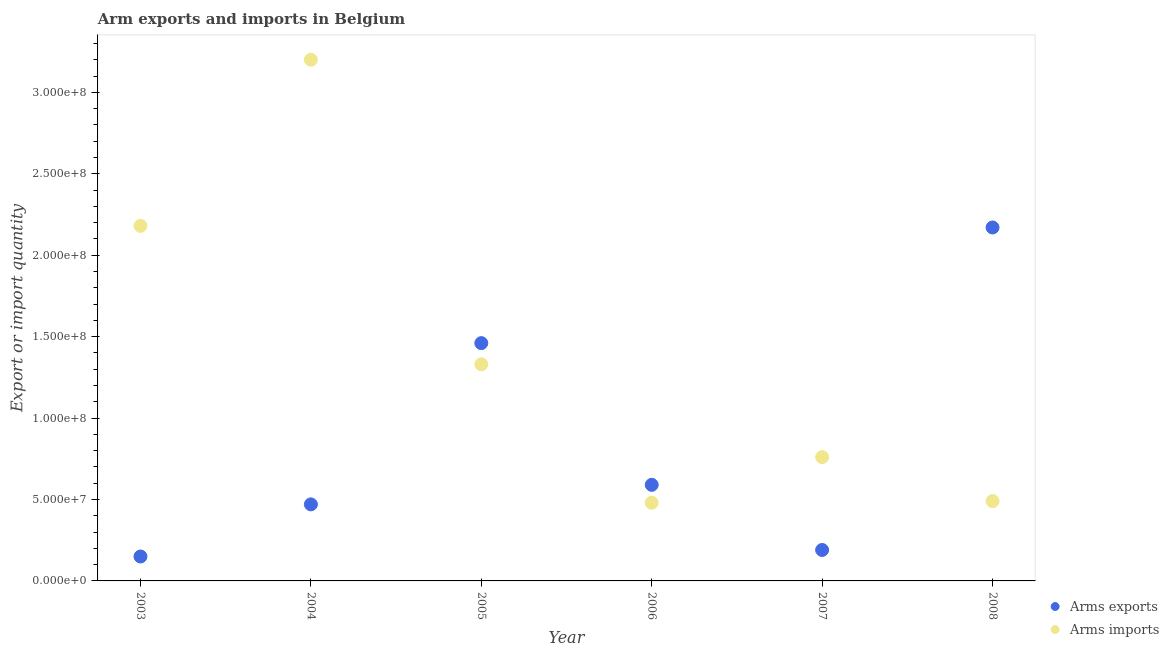How many different coloured dotlines are there?
Your answer should be compact. 2. Is the number of dotlines equal to the number of legend labels?
Keep it short and to the point. Yes. What is the arms imports in 2008?
Provide a short and direct response. 4.90e+07. Across all years, what is the maximum arms imports?
Keep it short and to the point. 3.20e+08. Across all years, what is the minimum arms imports?
Give a very brief answer. 4.80e+07. In which year was the arms exports maximum?
Offer a terse response. 2008. What is the total arms imports in the graph?
Your answer should be very brief. 8.44e+08. What is the difference between the arms imports in 2003 and that in 2006?
Give a very brief answer. 1.70e+08. What is the difference between the arms exports in 2008 and the arms imports in 2005?
Give a very brief answer. 8.40e+07. What is the average arms imports per year?
Your answer should be compact. 1.41e+08. In the year 2007, what is the difference between the arms imports and arms exports?
Make the answer very short. 5.70e+07. In how many years, is the arms exports greater than 220000000?
Give a very brief answer. 0. What is the ratio of the arms imports in 2003 to that in 2004?
Your answer should be compact. 0.68. Is the arms exports in 2004 less than that in 2008?
Offer a very short reply. Yes. What is the difference between the highest and the second highest arms exports?
Your answer should be compact. 7.10e+07. What is the difference between the highest and the lowest arms imports?
Provide a short and direct response. 2.72e+08. In how many years, is the arms imports greater than the average arms imports taken over all years?
Offer a terse response. 2. Does the arms exports monotonically increase over the years?
Offer a terse response. No. Is the arms imports strictly greater than the arms exports over the years?
Offer a very short reply. No. How many years are there in the graph?
Your answer should be very brief. 6. Are the values on the major ticks of Y-axis written in scientific E-notation?
Offer a very short reply. Yes. How many legend labels are there?
Your response must be concise. 2. What is the title of the graph?
Ensure brevity in your answer.  Arm exports and imports in Belgium. What is the label or title of the X-axis?
Offer a terse response. Year. What is the label or title of the Y-axis?
Make the answer very short. Export or import quantity. What is the Export or import quantity of Arms exports in 2003?
Offer a terse response. 1.50e+07. What is the Export or import quantity of Arms imports in 2003?
Give a very brief answer. 2.18e+08. What is the Export or import quantity in Arms exports in 2004?
Your answer should be compact. 4.70e+07. What is the Export or import quantity of Arms imports in 2004?
Offer a terse response. 3.20e+08. What is the Export or import quantity in Arms exports in 2005?
Offer a terse response. 1.46e+08. What is the Export or import quantity of Arms imports in 2005?
Your answer should be very brief. 1.33e+08. What is the Export or import quantity of Arms exports in 2006?
Provide a short and direct response. 5.90e+07. What is the Export or import quantity in Arms imports in 2006?
Offer a very short reply. 4.80e+07. What is the Export or import quantity in Arms exports in 2007?
Your answer should be compact. 1.90e+07. What is the Export or import quantity in Arms imports in 2007?
Offer a terse response. 7.60e+07. What is the Export or import quantity in Arms exports in 2008?
Provide a succinct answer. 2.17e+08. What is the Export or import quantity of Arms imports in 2008?
Your answer should be very brief. 4.90e+07. Across all years, what is the maximum Export or import quantity in Arms exports?
Offer a very short reply. 2.17e+08. Across all years, what is the maximum Export or import quantity of Arms imports?
Your answer should be compact. 3.20e+08. Across all years, what is the minimum Export or import quantity in Arms exports?
Provide a succinct answer. 1.50e+07. Across all years, what is the minimum Export or import quantity of Arms imports?
Your answer should be compact. 4.80e+07. What is the total Export or import quantity of Arms exports in the graph?
Provide a succinct answer. 5.03e+08. What is the total Export or import quantity of Arms imports in the graph?
Give a very brief answer. 8.44e+08. What is the difference between the Export or import quantity in Arms exports in 2003 and that in 2004?
Give a very brief answer. -3.20e+07. What is the difference between the Export or import quantity of Arms imports in 2003 and that in 2004?
Make the answer very short. -1.02e+08. What is the difference between the Export or import quantity in Arms exports in 2003 and that in 2005?
Provide a short and direct response. -1.31e+08. What is the difference between the Export or import quantity in Arms imports in 2003 and that in 2005?
Give a very brief answer. 8.50e+07. What is the difference between the Export or import quantity in Arms exports in 2003 and that in 2006?
Make the answer very short. -4.40e+07. What is the difference between the Export or import quantity of Arms imports in 2003 and that in 2006?
Provide a succinct answer. 1.70e+08. What is the difference between the Export or import quantity in Arms imports in 2003 and that in 2007?
Your response must be concise. 1.42e+08. What is the difference between the Export or import quantity of Arms exports in 2003 and that in 2008?
Provide a short and direct response. -2.02e+08. What is the difference between the Export or import quantity of Arms imports in 2003 and that in 2008?
Ensure brevity in your answer.  1.69e+08. What is the difference between the Export or import quantity of Arms exports in 2004 and that in 2005?
Ensure brevity in your answer.  -9.90e+07. What is the difference between the Export or import quantity of Arms imports in 2004 and that in 2005?
Give a very brief answer. 1.87e+08. What is the difference between the Export or import quantity of Arms exports in 2004 and that in 2006?
Your answer should be compact. -1.20e+07. What is the difference between the Export or import quantity in Arms imports in 2004 and that in 2006?
Your answer should be compact. 2.72e+08. What is the difference between the Export or import quantity of Arms exports in 2004 and that in 2007?
Offer a very short reply. 2.80e+07. What is the difference between the Export or import quantity of Arms imports in 2004 and that in 2007?
Offer a very short reply. 2.44e+08. What is the difference between the Export or import quantity in Arms exports in 2004 and that in 2008?
Your answer should be very brief. -1.70e+08. What is the difference between the Export or import quantity of Arms imports in 2004 and that in 2008?
Offer a terse response. 2.71e+08. What is the difference between the Export or import quantity in Arms exports in 2005 and that in 2006?
Your response must be concise. 8.70e+07. What is the difference between the Export or import quantity of Arms imports in 2005 and that in 2006?
Keep it short and to the point. 8.50e+07. What is the difference between the Export or import quantity in Arms exports in 2005 and that in 2007?
Offer a terse response. 1.27e+08. What is the difference between the Export or import quantity of Arms imports in 2005 and that in 2007?
Your answer should be very brief. 5.70e+07. What is the difference between the Export or import quantity in Arms exports in 2005 and that in 2008?
Make the answer very short. -7.10e+07. What is the difference between the Export or import quantity of Arms imports in 2005 and that in 2008?
Provide a short and direct response. 8.40e+07. What is the difference between the Export or import quantity of Arms exports in 2006 and that in 2007?
Keep it short and to the point. 4.00e+07. What is the difference between the Export or import quantity of Arms imports in 2006 and that in 2007?
Offer a very short reply. -2.80e+07. What is the difference between the Export or import quantity of Arms exports in 2006 and that in 2008?
Your answer should be compact. -1.58e+08. What is the difference between the Export or import quantity of Arms exports in 2007 and that in 2008?
Your answer should be compact. -1.98e+08. What is the difference between the Export or import quantity of Arms imports in 2007 and that in 2008?
Ensure brevity in your answer.  2.70e+07. What is the difference between the Export or import quantity in Arms exports in 2003 and the Export or import quantity in Arms imports in 2004?
Give a very brief answer. -3.05e+08. What is the difference between the Export or import quantity in Arms exports in 2003 and the Export or import quantity in Arms imports in 2005?
Your answer should be very brief. -1.18e+08. What is the difference between the Export or import quantity in Arms exports in 2003 and the Export or import quantity in Arms imports in 2006?
Your response must be concise. -3.30e+07. What is the difference between the Export or import quantity in Arms exports in 2003 and the Export or import quantity in Arms imports in 2007?
Give a very brief answer. -6.10e+07. What is the difference between the Export or import quantity in Arms exports in 2003 and the Export or import quantity in Arms imports in 2008?
Your answer should be compact. -3.40e+07. What is the difference between the Export or import quantity in Arms exports in 2004 and the Export or import quantity in Arms imports in 2005?
Your answer should be very brief. -8.60e+07. What is the difference between the Export or import quantity in Arms exports in 2004 and the Export or import quantity in Arms imports in 2006?
Make the answer very short. -1.00e+06. What is the difference between the Export or import quantity of Arms exports in 2004 and the Export or import quantity of Arms imports in 2007?
Ensure brevity in your answer.  -2.90e+07. What is the difference between the Export or import quantity of Arms exports in 2005 and the Export or import quantity of Arms imports in 2006?
Give a very brief answer. 9.80e+07. What is the difference between the Export or import quantity in Arms exports in 2005 and the Export or import quantity in Arms imports in 2007?
Your answer should be compact. 7.00e+07. What is the difference between the Export or import quantity in Arms exports in 2005 and the Export or import quantity in Arms imports in 2008?
Your response must be concise. 9.70e+07. What is the difference between the Export or import quantity of Arms exports in 2006 and the Export or import quantity of Arms imports in 2007?
Offer a very short reply. -1.70e+07. What is the difference between the Export or import quantity of Arms exports in 2006 and the Export or import quantity of Arms imports in 2008?
Your response must be concise. 1.00e+07. What is the difference between the Export or import quantity of Arms exports in 2007 and the Export or import quantity of Arms imports in 2008?
Provide a succinct answer. -3.00e+07. What is the average Export or import quantity in Arms exports per year?
Provide a short and direct response. 8.38e+07. What is the average Export or import quantity in Arms imports per year?
Offer a terse response. 1.41e+08. In the year 2003, what is the difference between the Export or import quantity of Arms exports and Export or import quantity of Arms imports?
Keep it short and to the point. -2.03e+08. In the year 2004, what is the difference between the Export or import quantity of Arms exports and Export or import quantity of Arms imports?
Your answer should be very brief. -2.73e+08. In the year 2005, what is the difference between the Export or import quantity in Arms exports and Export or import quantity in Arms imports?
Provide a succinct answer. 1.30e+07. In the year 2006, what is the difference between the Export or import quantity of Arms exports and Export or import quantity of Arms imports?
Provide a short and direct response. 1.10e+07. In the year 2007, what is the difference between the Export or import quantity of Arms exports and Export or import quantity of Arms imports?
Your answer should be very brief. -5.70e+07. In the year 2008, what is the difference between the Export or import quantity of Arms exports and Export or import quantity of Arms imports?
Offer a terse response. 1.68e+08. What is the ratio of the Export or import quantity in Arms exports in 2003 to that in 2004?
Keep it short and to the point. 0.32. What is the ratio of the Export or import quantity in Arms imports in 2003 to that in 2004?
Your answer should be very brief. 0.68. What is the ratio of the Export or import quantity in Arms exports in 2003 to that in 2005?
Ensure brevity in your answer.  0.1. What is the ratio of the Export or import quantity in Arms imports in 2003 to that in 2005?
Make the answer very short. 1.64. What is the ratio of the Export or import quantity of Arms exports in 2003 to that in 2006?
Your answer should be compact. 0.25. What is the ratio of the Export or import quantity in Arms imports in 2003 to that in 2006?
Make the answer very short. 4.54. What is the ratio of the Export or import quantity in Arms exports in 2003 to that in 2007?
Provide a succinct answer. 0.79. What is the ratio of the Export or import quantity of Arms imports in 2003 to that in 2007?
Your answer should be very brief. 2.87. What is the ratio of the Export or import quantity in Arms exports in 2003 to that in 2008?
Provide a short and direct response. 0.07. What is the ratio of the Export or import quantity of Arms imports in 2003 to that in 2008?
Give a very brief answer. 4.45. What is the ratio of the Export or import quantity in Arms exports in 2004 to that in 2005?
Offer a terse response. 0.32. What is the ratio of the Export or import quantity in Arms imports in 2004 to that in 2005?
Keep it short and to the point. 2.41. What is the ratio of the Export or import quantity of Arms exports in 2004 to that in 2006?
Your answer should be very brief. 0.8. What is the ratio of the Export or import quantity in Arms imports in 2004 to that in 2006?
Provide a succinct answer. 6.67. What is the ratio of the Export or import quantity in Arms exports in 2004 to that in 2007?
Keep it short and to the point. 2.47. What is the ratio of the Export or import quantity of Arms imports in 2004 to that in 2007?
Offer a very short reply. 4.21. What is the ratio of the Export or import quantity in Arms exports in 2004 to that in 2008?
Keep it short and to the point. 0.22. What is the ratio of the Export or import quantity in Arms imports in 2004 to that in 2008?
Provide a short and direct response. 6.53. What is the ratio of the Export or import quantity in Arms exports in 2005 to that in 2006?
Offer a terse response. 2.47. What is the ratio of the Export or import quantity in Arms imports in 2005 to that in 2006?
Keep it short and to the point. 2.77. What is the ratio of the Export or import quantity of Arms exports in 2005 to that in 2007?
Offer a very short reply. 7.68. What is the ratio of the Export or import quantity of Arms imports in 2005 to that in 2007?
Provide a short and direct response. 1.75. What is the ratio of the Export or import quantity of Arms exports in 2005 to that in 2008?
Keep it short and to the point. 0.67. What is the ratio of the Export or import quantity of Arms imports in 2005 to that in 2008?
Provide a succinct answer. 2.71. What is the ratio of the Export or import quantity of Arms exports in 2006 to that in 2007?
Your answer should be very brief. 3.11. What is the ratio of the Export or import quantity in Arms imports in 2006 to that in 2007?
Your answer should be very brief. 0.63. What is the ratio of the Export or import quantity of Arms exports in 2006 to that in 2008?
Offer a terse response. 0.27. What is the ratio of the Export or import quantity in Arms imports in 2006 to that in 2008?
Ensure brevity in your answer.  0.98. What is the ratio of the Export or import quantity in Arms exports in 2007 to that in 2008?
Give a very brief answer. 0.09. What is the ratio of the Export or import quantity of Arms imports in 2007 to that in 2008?
Ensure brevity in your answer.  1.55. What is the difference between the highest and the second highest Export or import quantity in Arms exports?
Your answer should be very brief. 7.10e+07. What is the difference between the highest and the second highest Export or import quantity of Arms imports?
Your response must be concise. 1.02e+08. What is the difference between the highest and the lowest Export or import quantity of Arms exports?
Provide a succinct answer. 2.02e+08. What is the difference between the highest and the lowest Export or import quantity in Arms imports?
Give a very brief answer. 2.72e+08. 